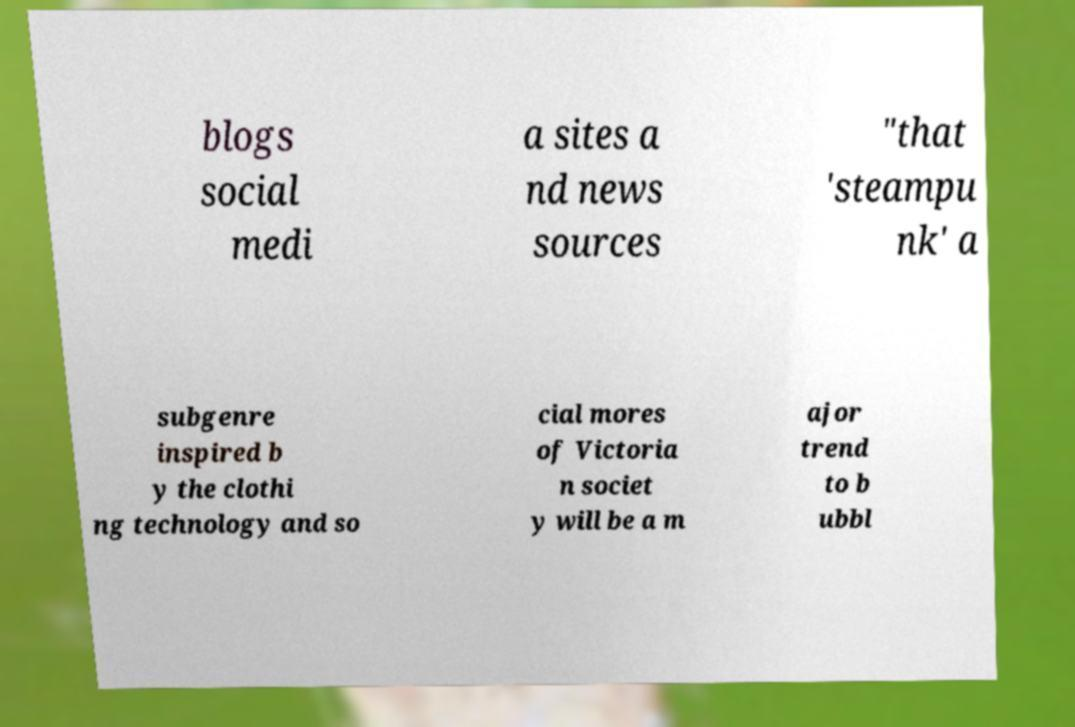There's text embedded in this image that I need extracted. Can you transcribe it verbatim? blogs social medi a sites a nd news sources "that 'steampu nk' a subgenre inspired b y the clothi ng technology and so cial mores of Victoria n societ y will be a m ajor trend to b ubbl 